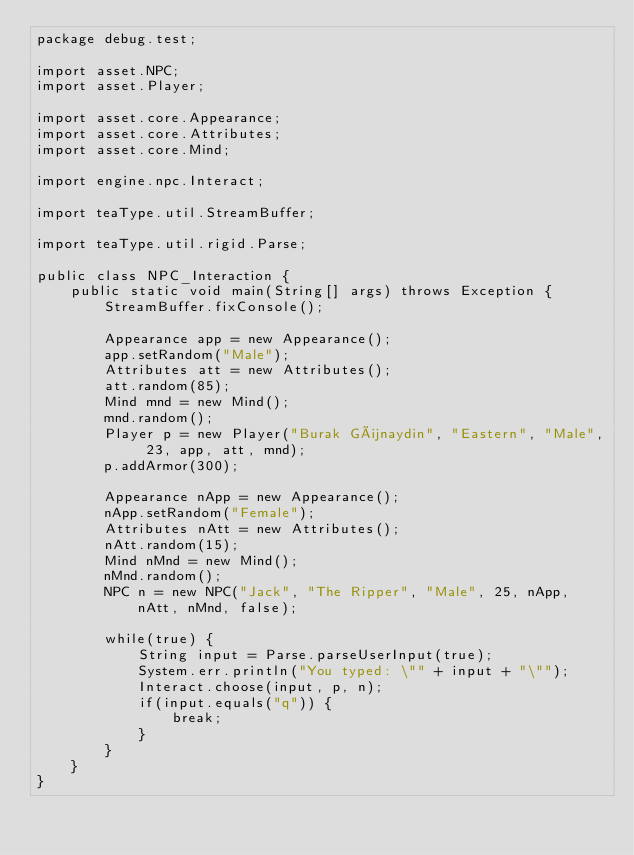Convert code to text. <code><loc_0><loc_0><loc_500><loc_500><_Java_>package debug.test;

import asset.NPC;
import asset.Player;

import asset.core.Appearance;
import asset.core.Attributes;
import asset.core.Mind;

import engine.npc.Interact;

import teaType.util.StreamBuffer;

import teaType.util.rigid.Parse;

public class NPC_Interaction {
	public static void main(String[] args) throws Exception {
		StreamBuffer.fixConsole();

		Appearance app = new Appearance();
		app.setRandom("Male");
		Attributes att = new Attributes();
		att.random(85);
		Mind mnd = new Mind();
		mnd.random();
		Player p = new Player("Burak Günaydin", "Eastern", "Male", 23, app, att, mnd);
		p.addArmor(300);

		Appearance nApp = new Appearance();
		nApp.setRandom("Female");
		Attributes nAtt = new Attributes();
		nAtt.random(15);
		Mind nMnd = new Mind();
		nMnd.random();
		NPC n = new NPC("Jack", "The Ripper", "Male", 25, nApp, nAtt, nMnd, false);
		
		while(true) {
			String input = Parse.parseUserInput(true);
			System.err.println("You typed: \"" + input + "\"");
			Interact.choose(input, p, n);
			if(input.equals("q")) {
				break;
			}
		}
	}
}</code> 